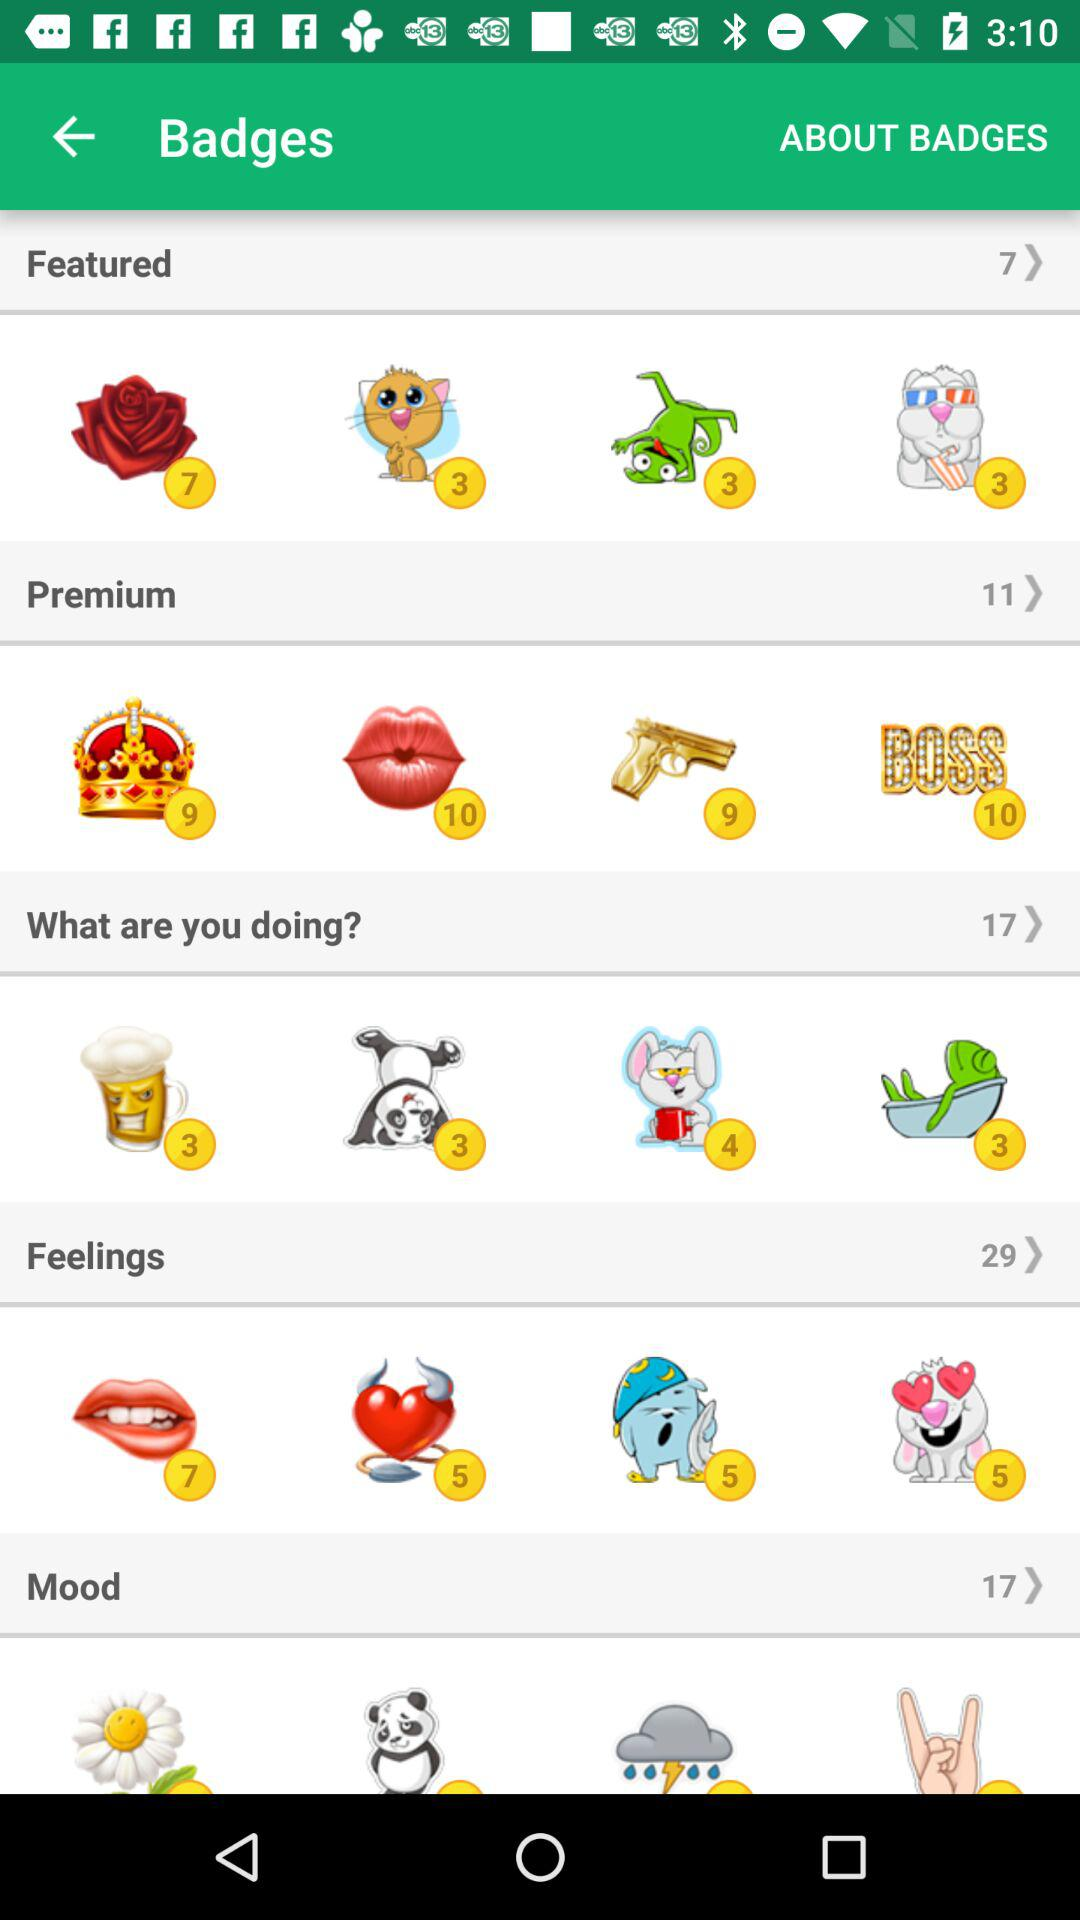What is the total number of badges in "Mood"? The total number of badges in "Mood" is 17. 